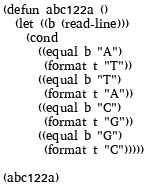Convert code to text. <code><loc_0><loc_0><loc_500><loc_500><_Lisp_>(defun abc122a ()
  (let ((b (read-line)))
    (cond
      ((equal b "A")
       (format t "T"))
      ((equal b "T")
       (format t "A"))
      ((equal b "C")
       (format t "G"))
      ((equal b "G")
       (format t "C")))))

(abc122a)</code> 